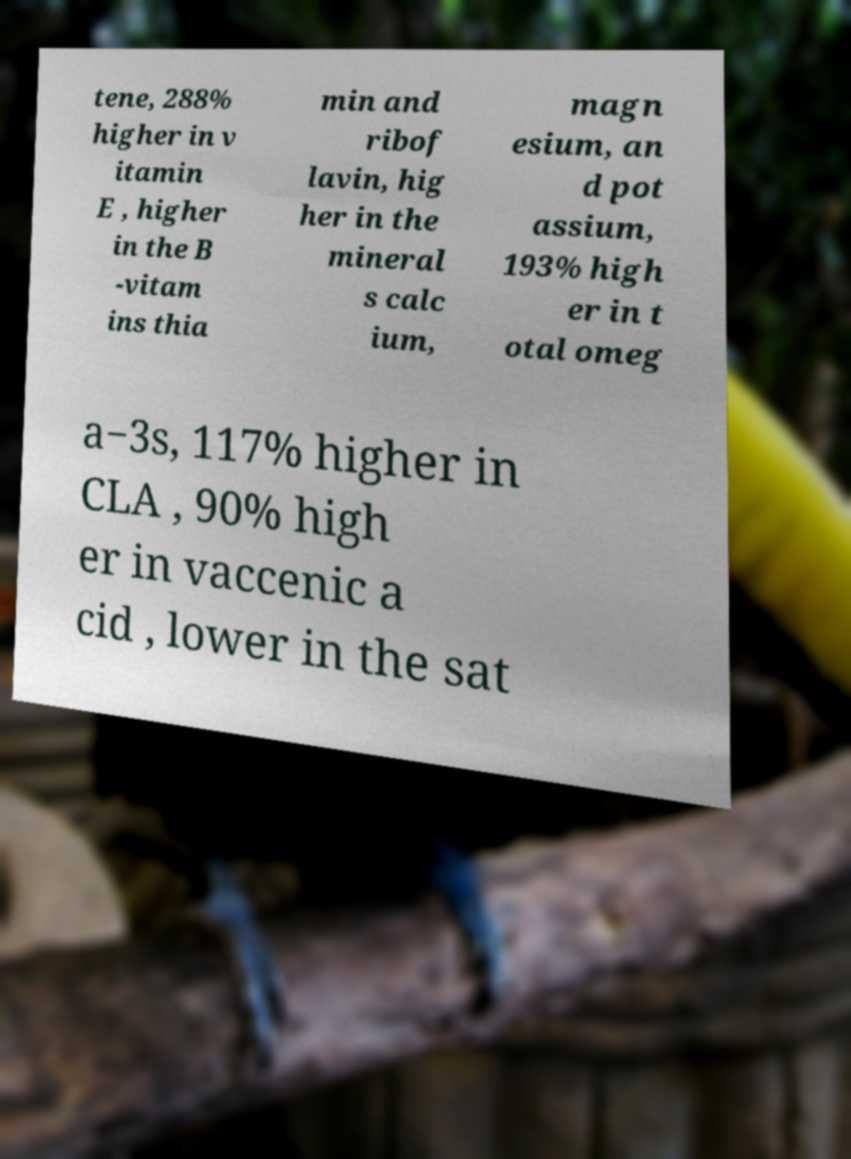Could you assist in decoding the text presented in this image and type it out clearly? tene, 288% higher in v itamin E , higher in the B -vitam ins thia min and ribof lavin, hig her in the mineral s calc ium, magn esium, an d pot assium, 193% high er in t otal omeg a−3s, 117% higher in CLA , 90% high er in vaccenic a cid , lower in the sat 